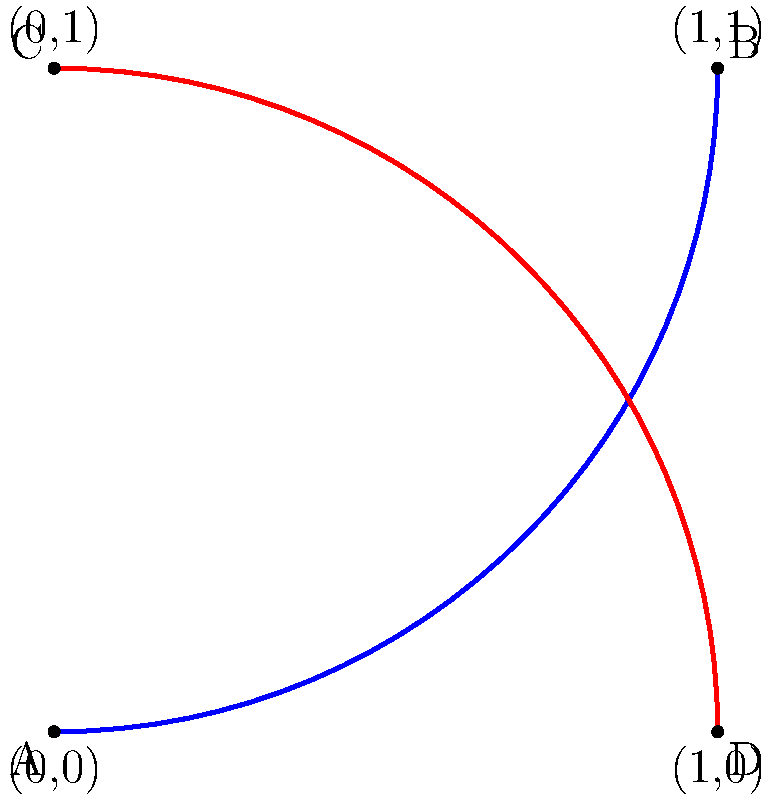In the context of knot theory, which type of knot is represented by the intertwined vinyl record grooves shown above, where the blue path represents Alex Chilton's "September Gurls" and the red path represents Big Star's "The Ballad of El Goodo"? To determine the type of knot represented by the intertwined vinyl record grooves, we need to follow these steps:

1. Identify the crossings: The diagram shows two paths (blue and red) crossing each other once in the center.

2. Analyze the crossing: At the crossing point, one path goes over the other. In knot theory, this is called a positive crossing.

3. Count the number of components: There are two distinct paths (blue and red) that are interlinked but not connected.

4. Recognize the knot type: When we have two closed loops that cross each other exactly once, forming a single positive crossing, this configuration is known as the Hopf link.

5. Understand the significance: The Hopf link is one of the simplest non-trivial links in knot theory. It consists of two unknots (simple closed loops) that are linked together.

6. Relate to vinyl records: In this representation, each path (blue and red) can be thought of as a circular vinyl record groove that has been deformed to create the link. The intersection represents where the two songs' grooves would metaphorically "link" in musical history.

Therefore, the intertwined vinyl record grooves of Alex Chilton's "September Gurls" and Big Star's "The Ballad of El Goodo" form a Hopf link in knot theory.
Answer: Hopf link 